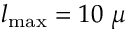<formula> <loc_0><loc_0><loc_500><loc_500>l _ { \max } = 1 0 \mu</formula> 